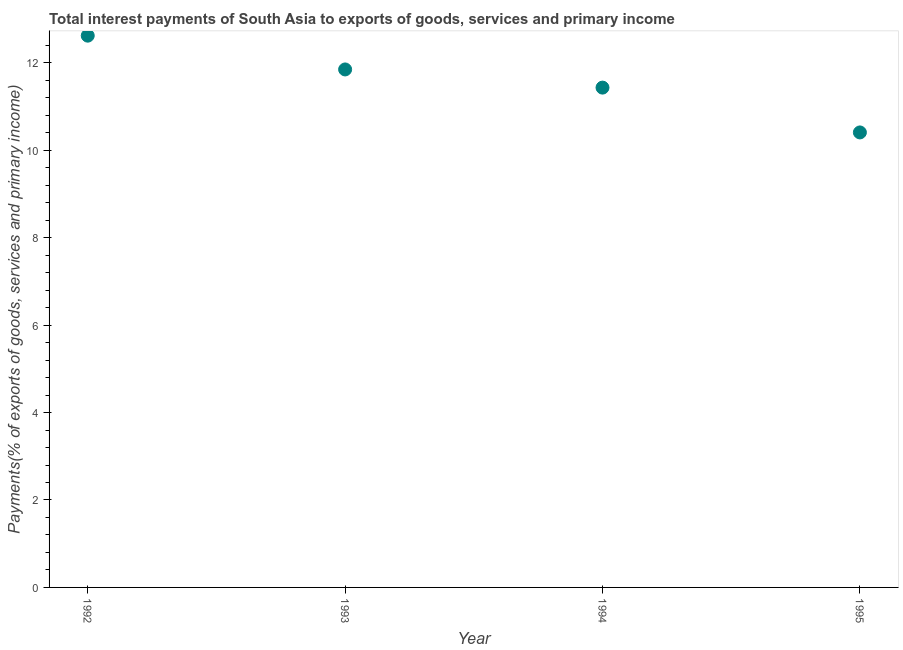What is the total interest payments on external debt in 1992?
Ensure brevity in your answer.  12.62. Across all years, what is the maximum total interest payments on external debt?
Give a very brief answer. 12.62. Across all years, what is the minimum total interest payments on external debt?
Offer a terse response. 10.41. In which year was the total interest payments on external debt maximum?
Offer a terse response. 1992. What is the sum of the total interest payments on external debt?
Offer a terse response. 46.31. What is the difference between the total interest payments on external debt in 1994 and 1995?
Your answer should be very brief. 1.02. What is the average total interest payments on external debt per year?
Offer a very short reply. 11.58. What is the median total interest payments on external debt?
Give a very brief answer. 11.64. Do a majority of the years between 1993 and 1994 (inclusive) have total interest payments on external debt greater than 6.4 %?
Make the answer very short. Yes. What is the ratio of the total interest payments on external debt in 1994 to that in 1995?
Give a very brief answer. 1.1. Is the total interest payments on external debt in 1993 less than that in 1995?
Your response must be concise. No. Is the difference between the total interest payments on external debt in 1993 and 1994 greater than the difference between any two years?
Ensure brevity in your answer.  No. What is the difference between the highest and the second highest total interest payments on external debt?
Offer a very short reply. 0.77. Is the sum of the total interest payments on external debt in 1992 and 1995 greater than the maximum total interest payments on external debt across all years?
Your answer should be compact. Yes. What is the difference between the highest and the lowest total interest payments on external debt?
Ensure brevity in your answer.  2.21. Does the total interest payments on external debt monotonically increase over the years?
Offer a very short reply. No. What is the difference between two consecutive major ticks on the Y-axis?
Offer a terse response. 2. Does the graph contain grids?
Offer a terse response. No. What is the title of the graph?
Offer a terse response. Total interest payments of South Asia to exports of goods, services and primary income. What is the label or title of the X-axis?
Your answer should be compact. Year. What is the label or title of the Y-axis?
Your answer should be compact. Payments(% of exports of goods, services and primary income). What is the Payments(% of exports of goods, services and primary income) in 1992?
Provide a short and direct response. 12.62. What is the Payments(% of exports of goods, services and primary income) in 1993?
Offer a very short reply. 11.85. What is the Payments(% of exports of goods, services and primary income) in 1994?
Your answer should be very brief. 11.43. What is the Payments(% of exports of goods, services and primary income) in 1995?
Give a very brief answer. 10.41. What is the difference between the Payments(% of exports of goods, services and primary income) in 1992 and 1993?
Offer a terse response. 0.77. What is the difference between the Payments(% of exports of goods, services and primary income) in 1992 and 1994?
Provide a short and direct response. 1.19. What is the difference between the Payments(% of exports of goods, services and primary income) in 1992 and 1995?
Make the answer very short. 2.21. What is the difference between the Payments(% of exports of goods, services and primary income) in 1993 and 1994?
Provide a succinct answer. 0.42. What is the difference between the Payments(% of exports of goods, services and primary income) in 1993 and 1995?
Give a very brief answer. 1.44. What is the difference between the Payments(% of exports of goods, services and primary income) in 1994 and 1995?
Provide a short and direct response. 1.02. What is the ratio of the Payments(% of exports of goods, services and primary income) in 1992 to that in 1993?
Make the answer very short. 1.06. What is the ratio of the Payments(% of exports of goods, services and primary income) in 1992 to that in 1994?
Keep it short and to the point. 1.1. What is the ratio of the Payments(% of exports of goods, services and primary income) in 1992 to that in 1995?
Ensure brevity in your answer.  1.21. What is the ratio of the Payments(% of exports of goods, services and primary income) in 1993 to that in 1994?
Your response must be concise. 1.04. What is the ratio of the Payments(% of exports of goods, services and primary income) in 1993 to that in 1995?
Make the answer very short. 1.14. What is the ratio of the Payments(% of exports of goods, services and primary income) in 1994 to that in 1995?
Ensure brevity in your answer.  1.1. 